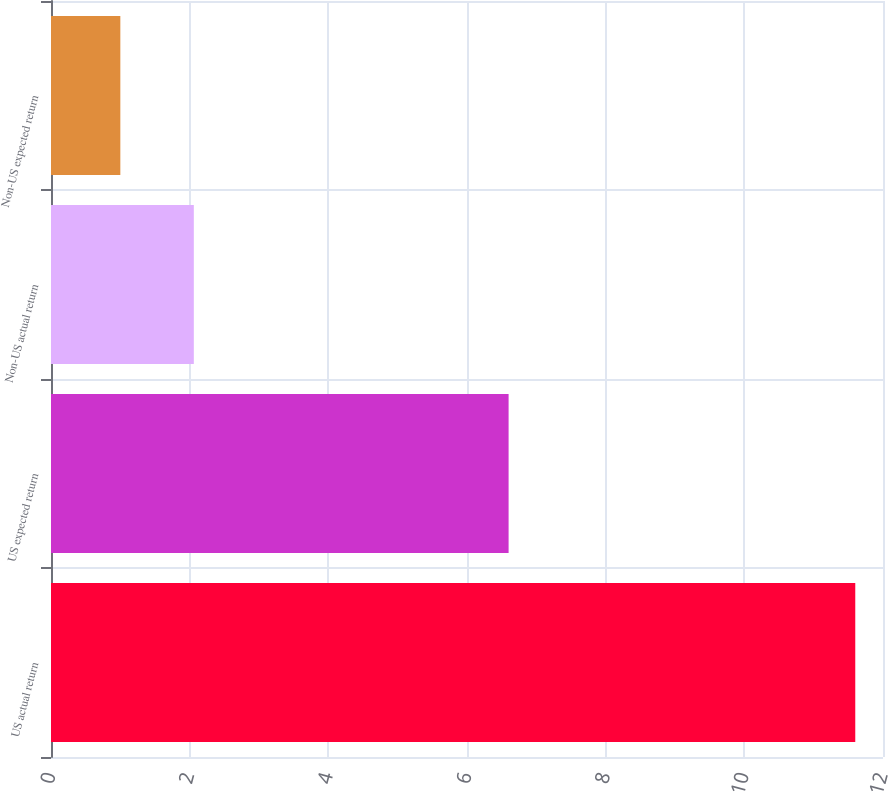Convert chart. <chart><loc_0><loc_0><loc_500><loc_500><bar_chart><fcel>US actual return<fcel>US expected return<fcel>Non-US actual return<fcel>Non-US expected return<nl><fcel>11.6<fcel>6.6<fcel>2.06<fcel>1<nl></chart> 